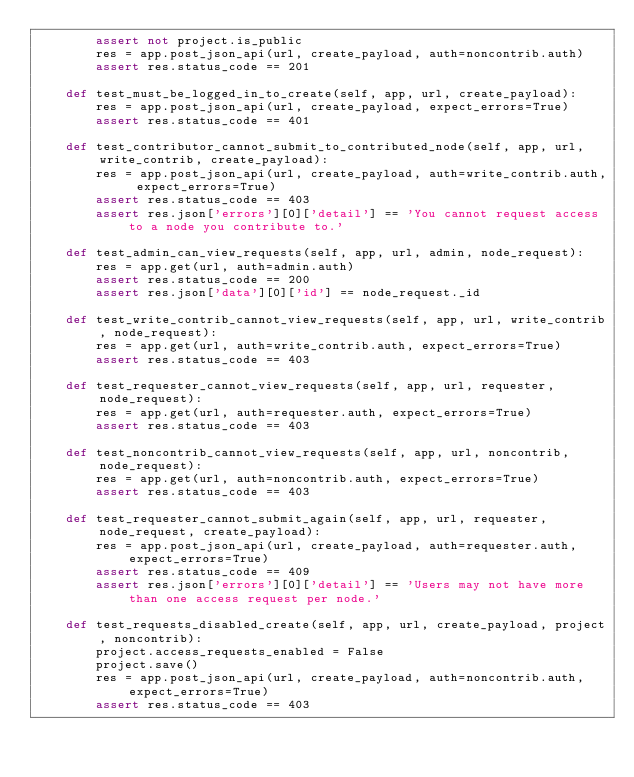<code> <loc_0><loc_0><loc_500><loc_500><_Python_>        assert not project.is_public
        res = app.post_json_api(url, create_payload, auth=noncontrib.auth)
        assert res.status_code == 201

    def test_must_be_logged_in_to_create(self, app, url, create_payload):
        res = app.post_json_api(url, create_payload, expect_errors=True)
        assert res.status_code == 401

    def test_contributor_cannot_submit_to_contributed_node(self, app, url, write_contrib, create_payload):
        res = app.post_json_api(url, create_payload, auth=write_contrib.auth, expect_errors=True)
        assert res.status_code == 403
        assert res.json['errors'][0]['detail'] == 'You cannot request access to a node you contribute to.'

    def test_admin_can_view_requests(self, app, url, admin, node_request):
        res = app.get(url, auth=admin.auth)
        assert res.status_code == 200
        assert res.json['data'][0]['id'] == node_request._id

    def test_write_contrib_cannot_view_requests(self, app, url, write_contrib, node_request):
        res = app.get(url, auth=write_contrib.auth, expect_errors=True)
        assert res.status_code == 403

    def test_requester_cannot_view_requests(self, app, url, requester, node_request):
        res = app.get(url, auth=requester.auth, expect_errors=True)
        assert res.status_code == 403

    def test_noncontrib_cannot_view_requests(self, app, url, noncontrib, node_request):
        res = app.get(url, auth=noncontrib.auth, expect_errors=True)
        assert res.status_code == 403

    def test_requester_cannot_submit_again(self, app, url, requester, node_request, create_payload):
        res = app.post_json_api(url, create_payload, auth=requester.auth, expect_errors=True)
        assert res.status_code == 409
        assert res.json['errors'][0]['detail'] == 'Users may not have more than one access request per node.'

    def test_requests_disabled_create(self, app, url, create_payload, project, noncontrib):
        project.access_requests_enabled = False
        project.save()
        res = app.post_json_api(url, create_payload, auth=noncontrib.auth, expect_errors=True)
        assert res.status_code == 403
</code> 